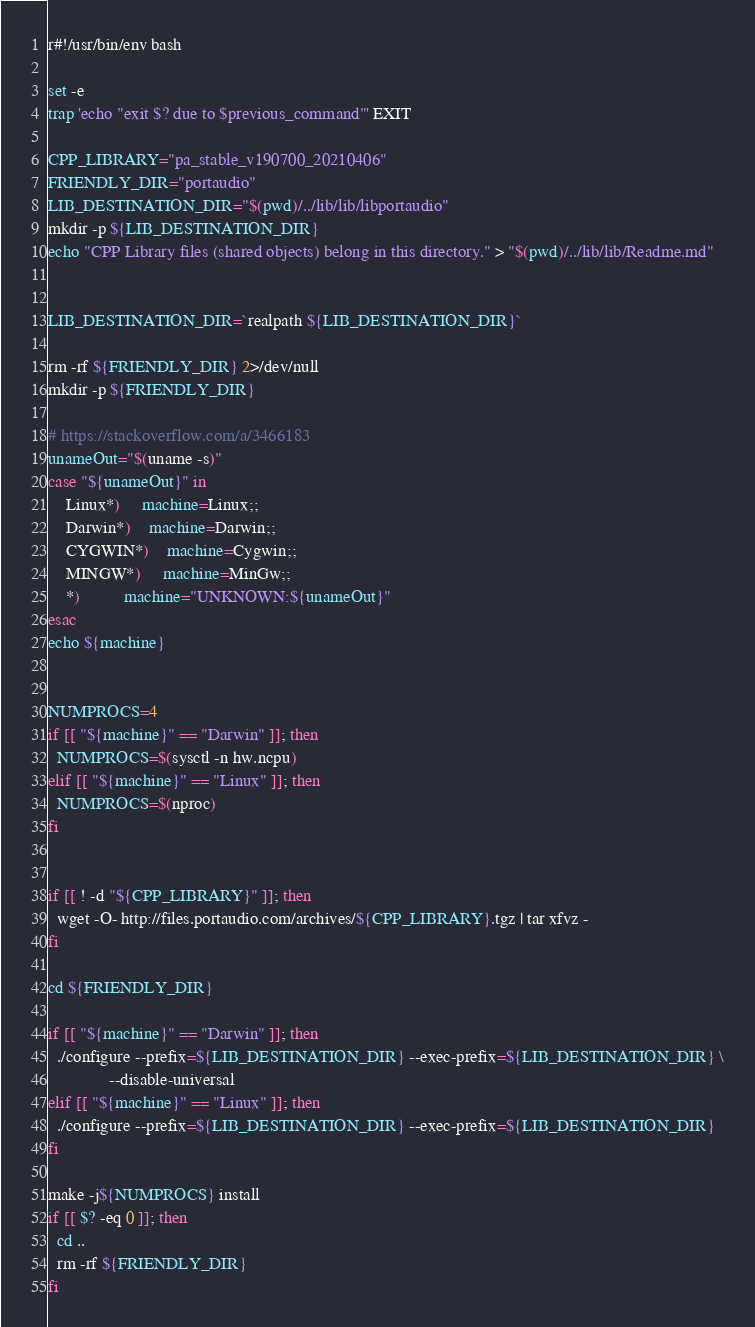<code> <loc_0><loc_0><loc_500><loc_500><_Bash_>r#!/usr/bin/env bash

set -e
trap 'echo "exit $? due to $previous_command"' EXIT

CPP_LIBRARY="pa_stable_v190700_20210406"
FRIENDLY_DIR="portaudio"
LIB_DESTINATION_DIR="$(pwd)/../lib/lib/libportaudio"
mkdir -p ${LIB_DESTINATION_DIR}
echo "CPP Library files (shared objects) belong in this directory." > "$(pwd)/../lib/lib/Readme.md"


LIB_DESTINATION_DIR=`realpath ${LIB_DESTINATION_DIR}`

rm -rf ${FRIENDLY_DIR} 2>/dev/null
mkdir -p ${FRIENDLY_DIR}

# https://stackoverflow.com/a/3466183
unameOut="$(uname -s)"
case "${unameOut}" in
    Linux*)     machine=Linux;;
    Darwin*)    machine=Darwin;;
    CYGWIN*)    machine=Cygwin;;
    MINGW*)     machine=MinGw;;
    *)          machine="UNKNOWN:${unameOut}"
esac
echo ${machine}


NUMPROCS=4
if [[ "${machine}" == "Darwin" ]]; then
  NUMPROCS=$(sysctl -n hw.ncpu)
elif [[ "${machine}" == "Linux" ]]; then
  NUMPROCS=$(nproc)
fi


if [[ ! -d "${CPP_LIBRARY}" ]]; then
  wget -O- http://files.portaudio.com/archives/${CPP_LIBRARY}.tgz | tar xfvz - 
fi

cd ${FRIENDLY_DIR}

if [[ "${machine}" == "Darwin" ]]; then
  ./configure --prefix=${LIB_DESTINATION_DIR} --exec-prefix=${LIB_DESTINATION_DIR} \
              --disable-universal 
elif [[ "${machine}" == "Linux" ]]; then
  ./configure --prefix=${LIB_DESTINATION_DIR} --exec-prefix=${LIB_DESTINATION_DIR}
fi

make -j${NUMPROCS} install
if [[ $? -eq 0 ]]; then
  cd ..
  rm -rf ${FRIENDLY_DIR}
fi




</code> 